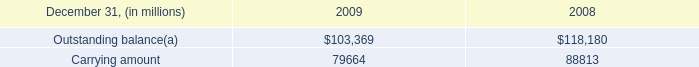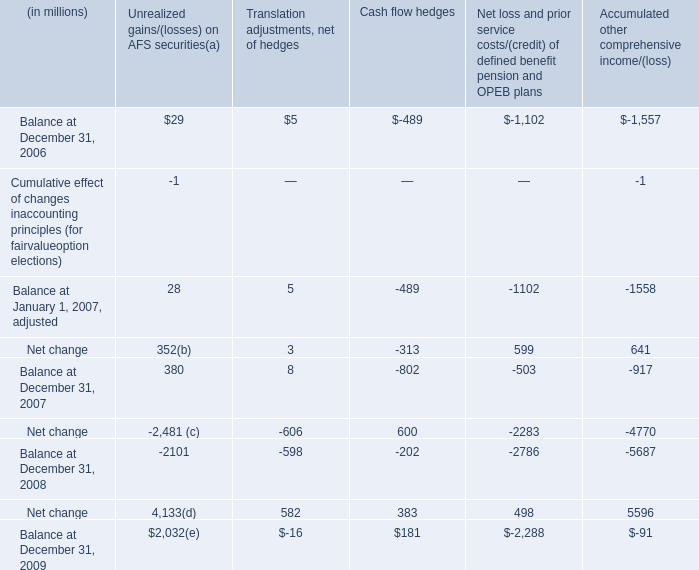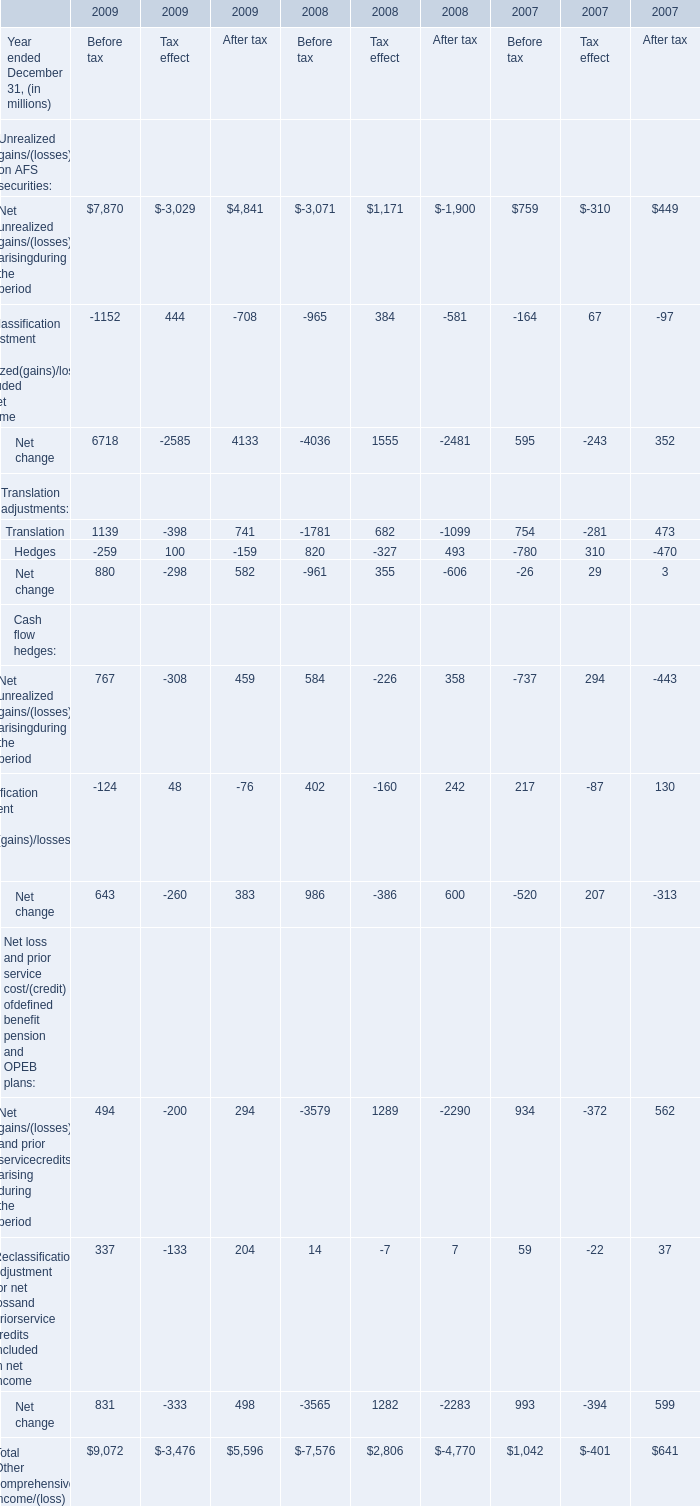What was the average of Translation for Before tax in 2009, 2008 and 2007? (in million) 
Computations: (((1139 - 1781) + 754) / 3)
Answer: 37.33333. 